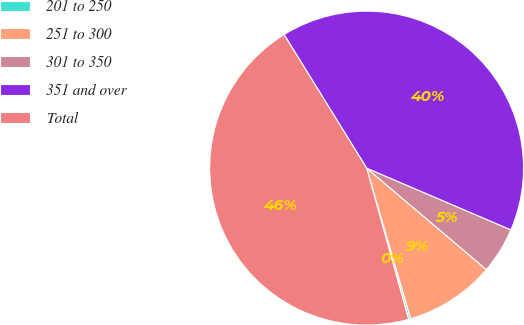Convert chart to OTSL. <chart><loc_0><loc_0><loc_500><loc_500><pie_chart><fcel>201 to 250<fcel>251 to 300<fcel>301 to 350<fcel>351 and over<fcel>Total<nl><fcel>0.22%<fcel>9.28%<fcel>4.75%<fcel>40.25%<fcel>45.5%<nl></chart> 